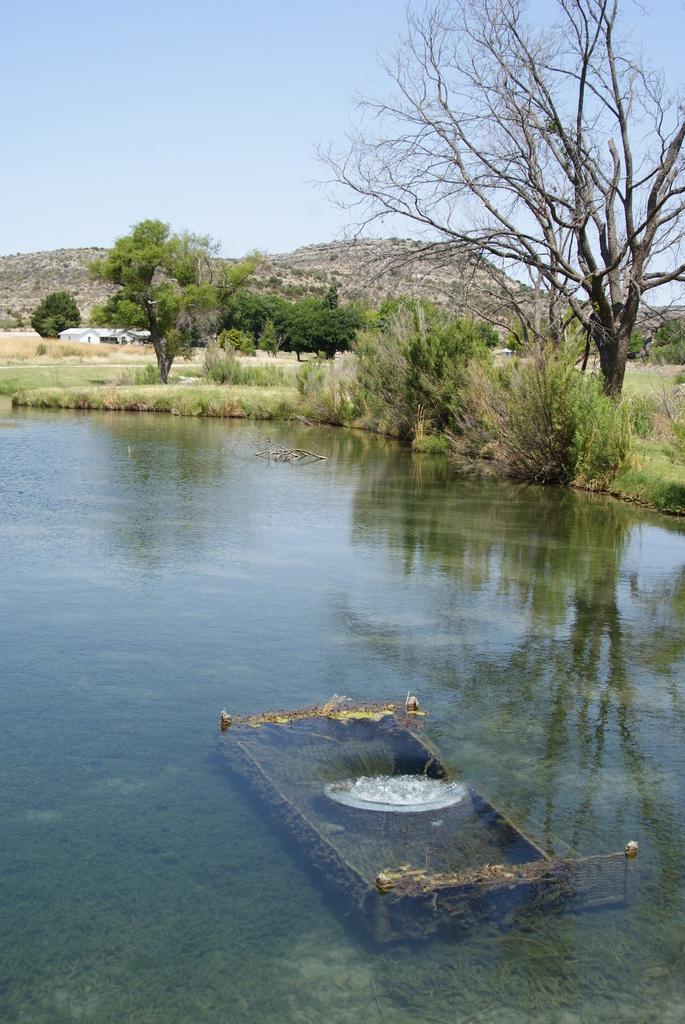Describe this image in one or two sentences. In this image we can see a lake and an object in it. There is a reflection of a sky and the trees on the water surface. There are many trees and plants in the image. There is a sky in the image. There is a house in the image. 